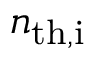<formula> <loc_0><loc_0><loc_500><loc_500>n _ { t h , i }</formula> 